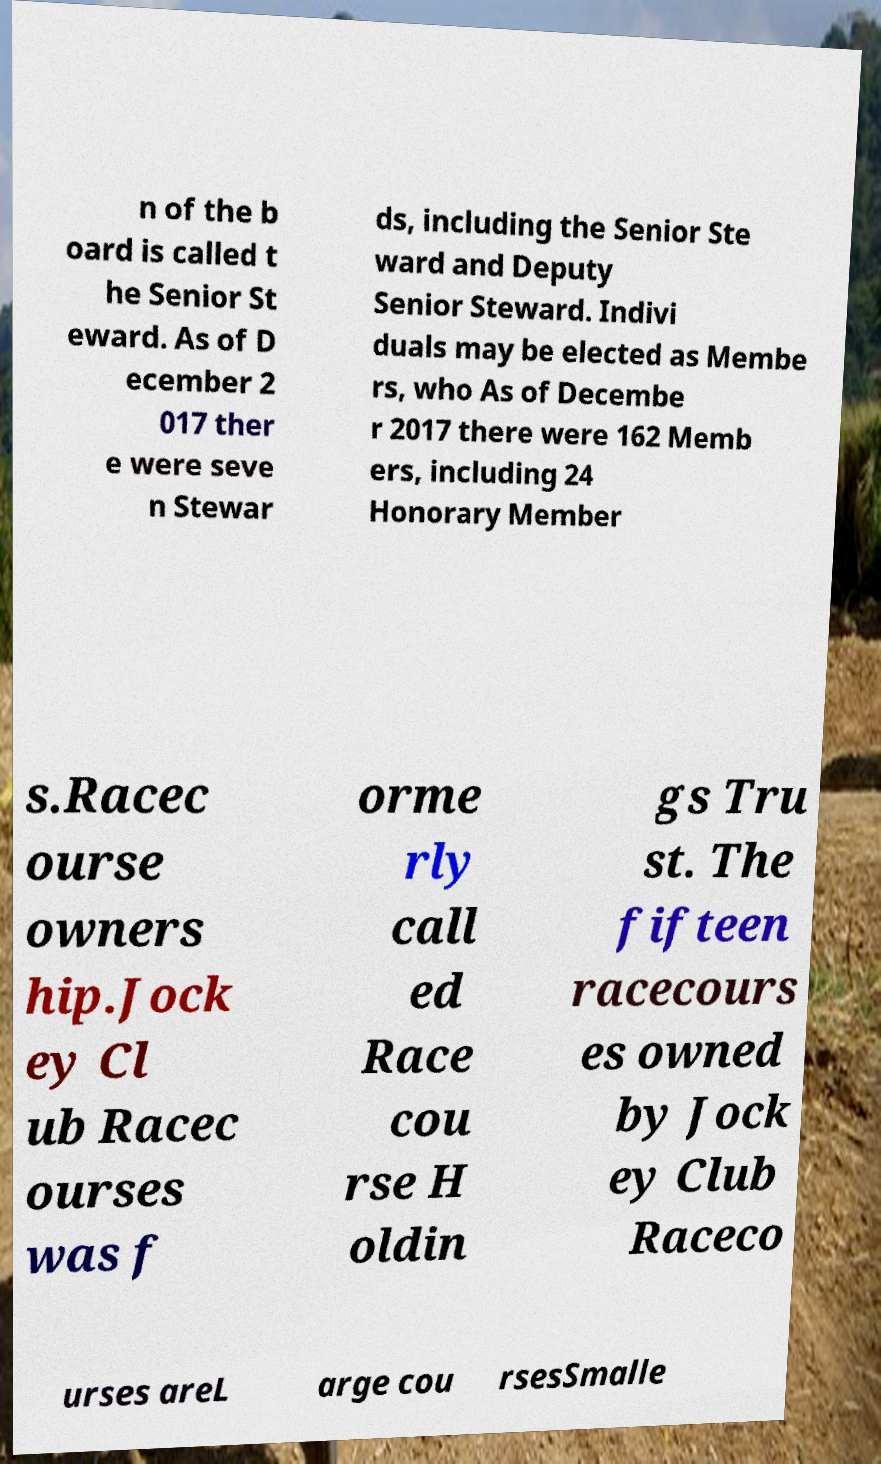For documentation purposes, I need the text within this image transcribed. Could you provide that? n of the b oard is called t he Senior St eward. As of D ecember 2 017 ther e were seve n Stewar ds, including the Senior Ste ward and Deputy Senior Steward. Indivi duals may be elected as Membe rs, who As of Decembe r 2017 there were 162 Memb ers, including 24 Honorary Member s.Racec ourse owners hip.Jock ey Cl ub Racec ourses was f orme rly call ed Race cou rse H oldin gs Tru st. The fifteen racecours es owned by Jock ey Club Raceco urses areL arge cou rsesSmalle 